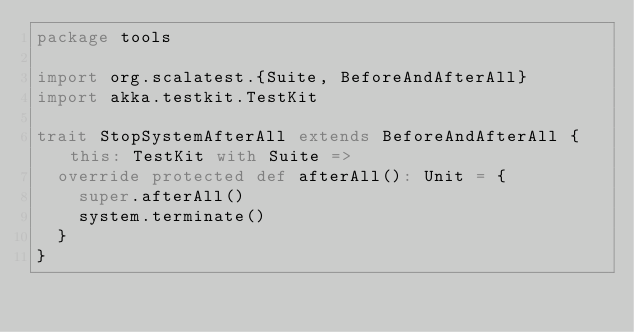<code> <loc_0><loc_0><loc_500><loc_500><_Scala_>package tools

import org.scalatest.{Suite, BeforeAndAfterAll}
import akka.testkit.TestKit

trait StopSystemAfterAll extends BeforeAndAfterAll { this: TestKit with Suite =>
  override protected def afterAll(): Unit = {
    super.afterAll()
    system.terminate()
  }
}
</code> 